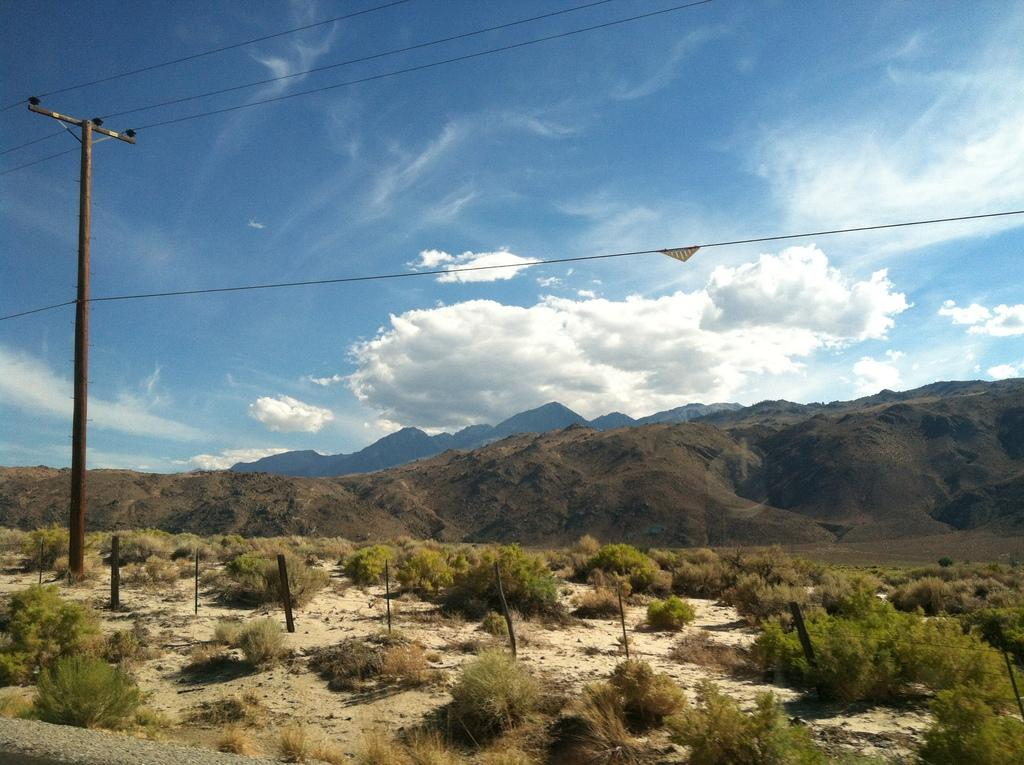What is the main structure visible in the image? There is an electric pole with cables in the image. What type of vegetation can be seen in the image? There are plants visible on the surface in the image. What can be seen in the distance in the image? There are mountains in the background of the image. Where are the books located in the image? There are no books present in the image. What type of plantation can be seen in the image? There is no plantation visible in the image; only plants are present. 